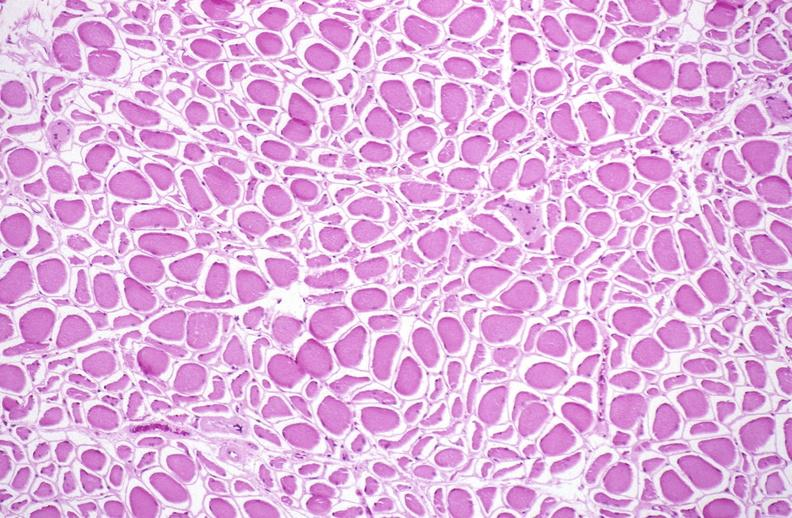does metastatic carcinoma show skeletal muscle atrophy?
Answer the question using a single word or phrase. No 